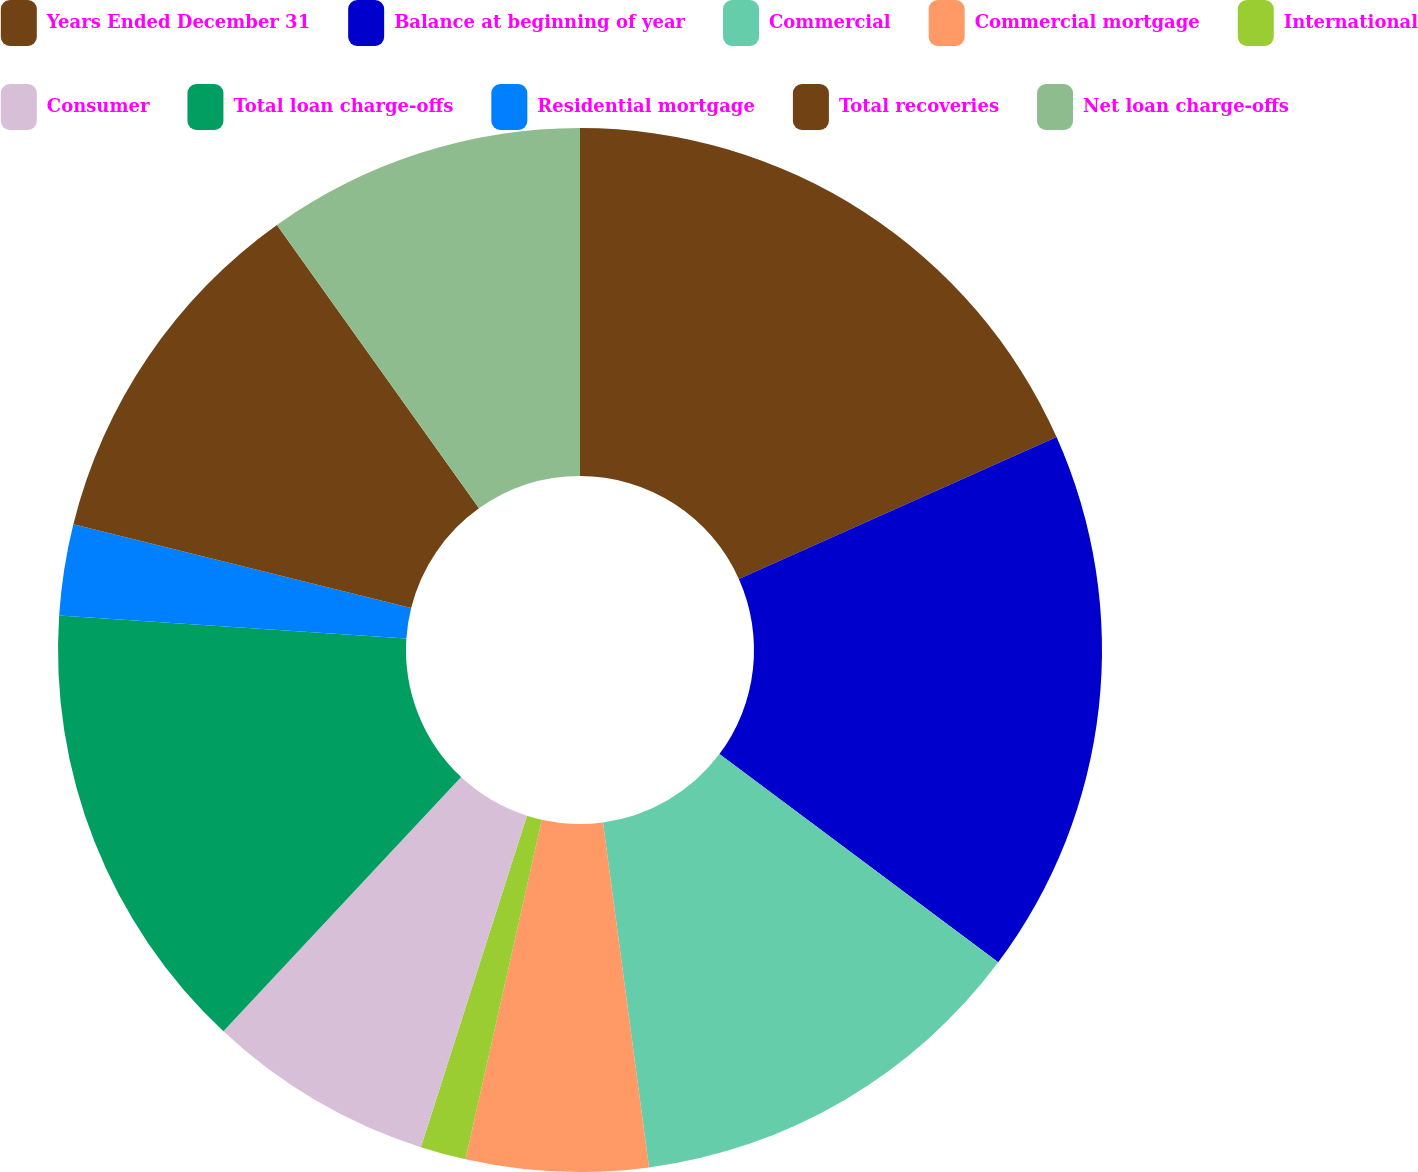Convert chart to OTSL. <chart><loc_0><loc_0><loc_500><loc_500><pie_chart><fcel>Years Ended December 31<fcel>Balance at beginning of year<fcel>Commercial<fcel>Commercial mortgage<fcel>International<fcel>Consumer<fcel>Total loan charge-offs<fcel>Residential mortgage<fcel>Total recoveries<fcel>Net loan charge-offs<nl><fcel>18.31%<fcel>16.9%<fcel>12.68%<fcel>5.63%<fcel>1.41%<fcel>7.04%<fcel>14.08%<fcel>2.82%<fcel>11.27%<fcel>9.86%<nl></chart> 